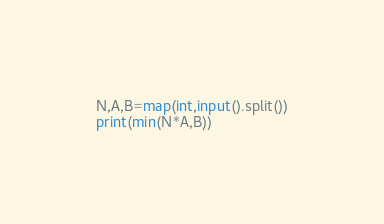Convert code to text. <code><loc_0><loc_0><loc_500><loc_500><_Python_>N,A,B=map(int,input().split())
print(min(N*A,B))</code> 